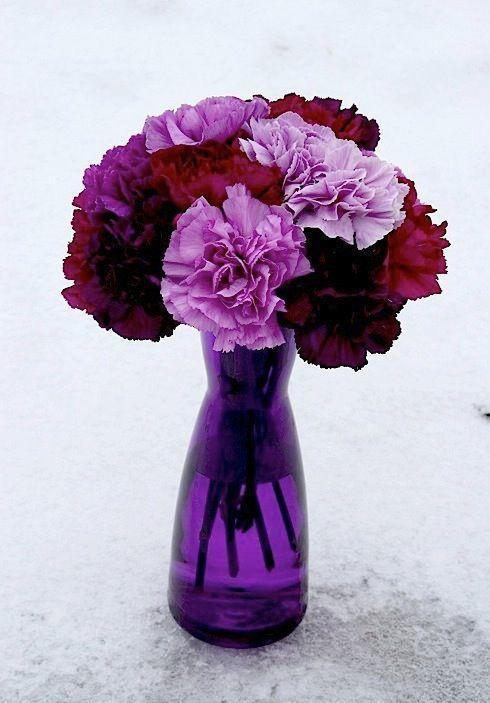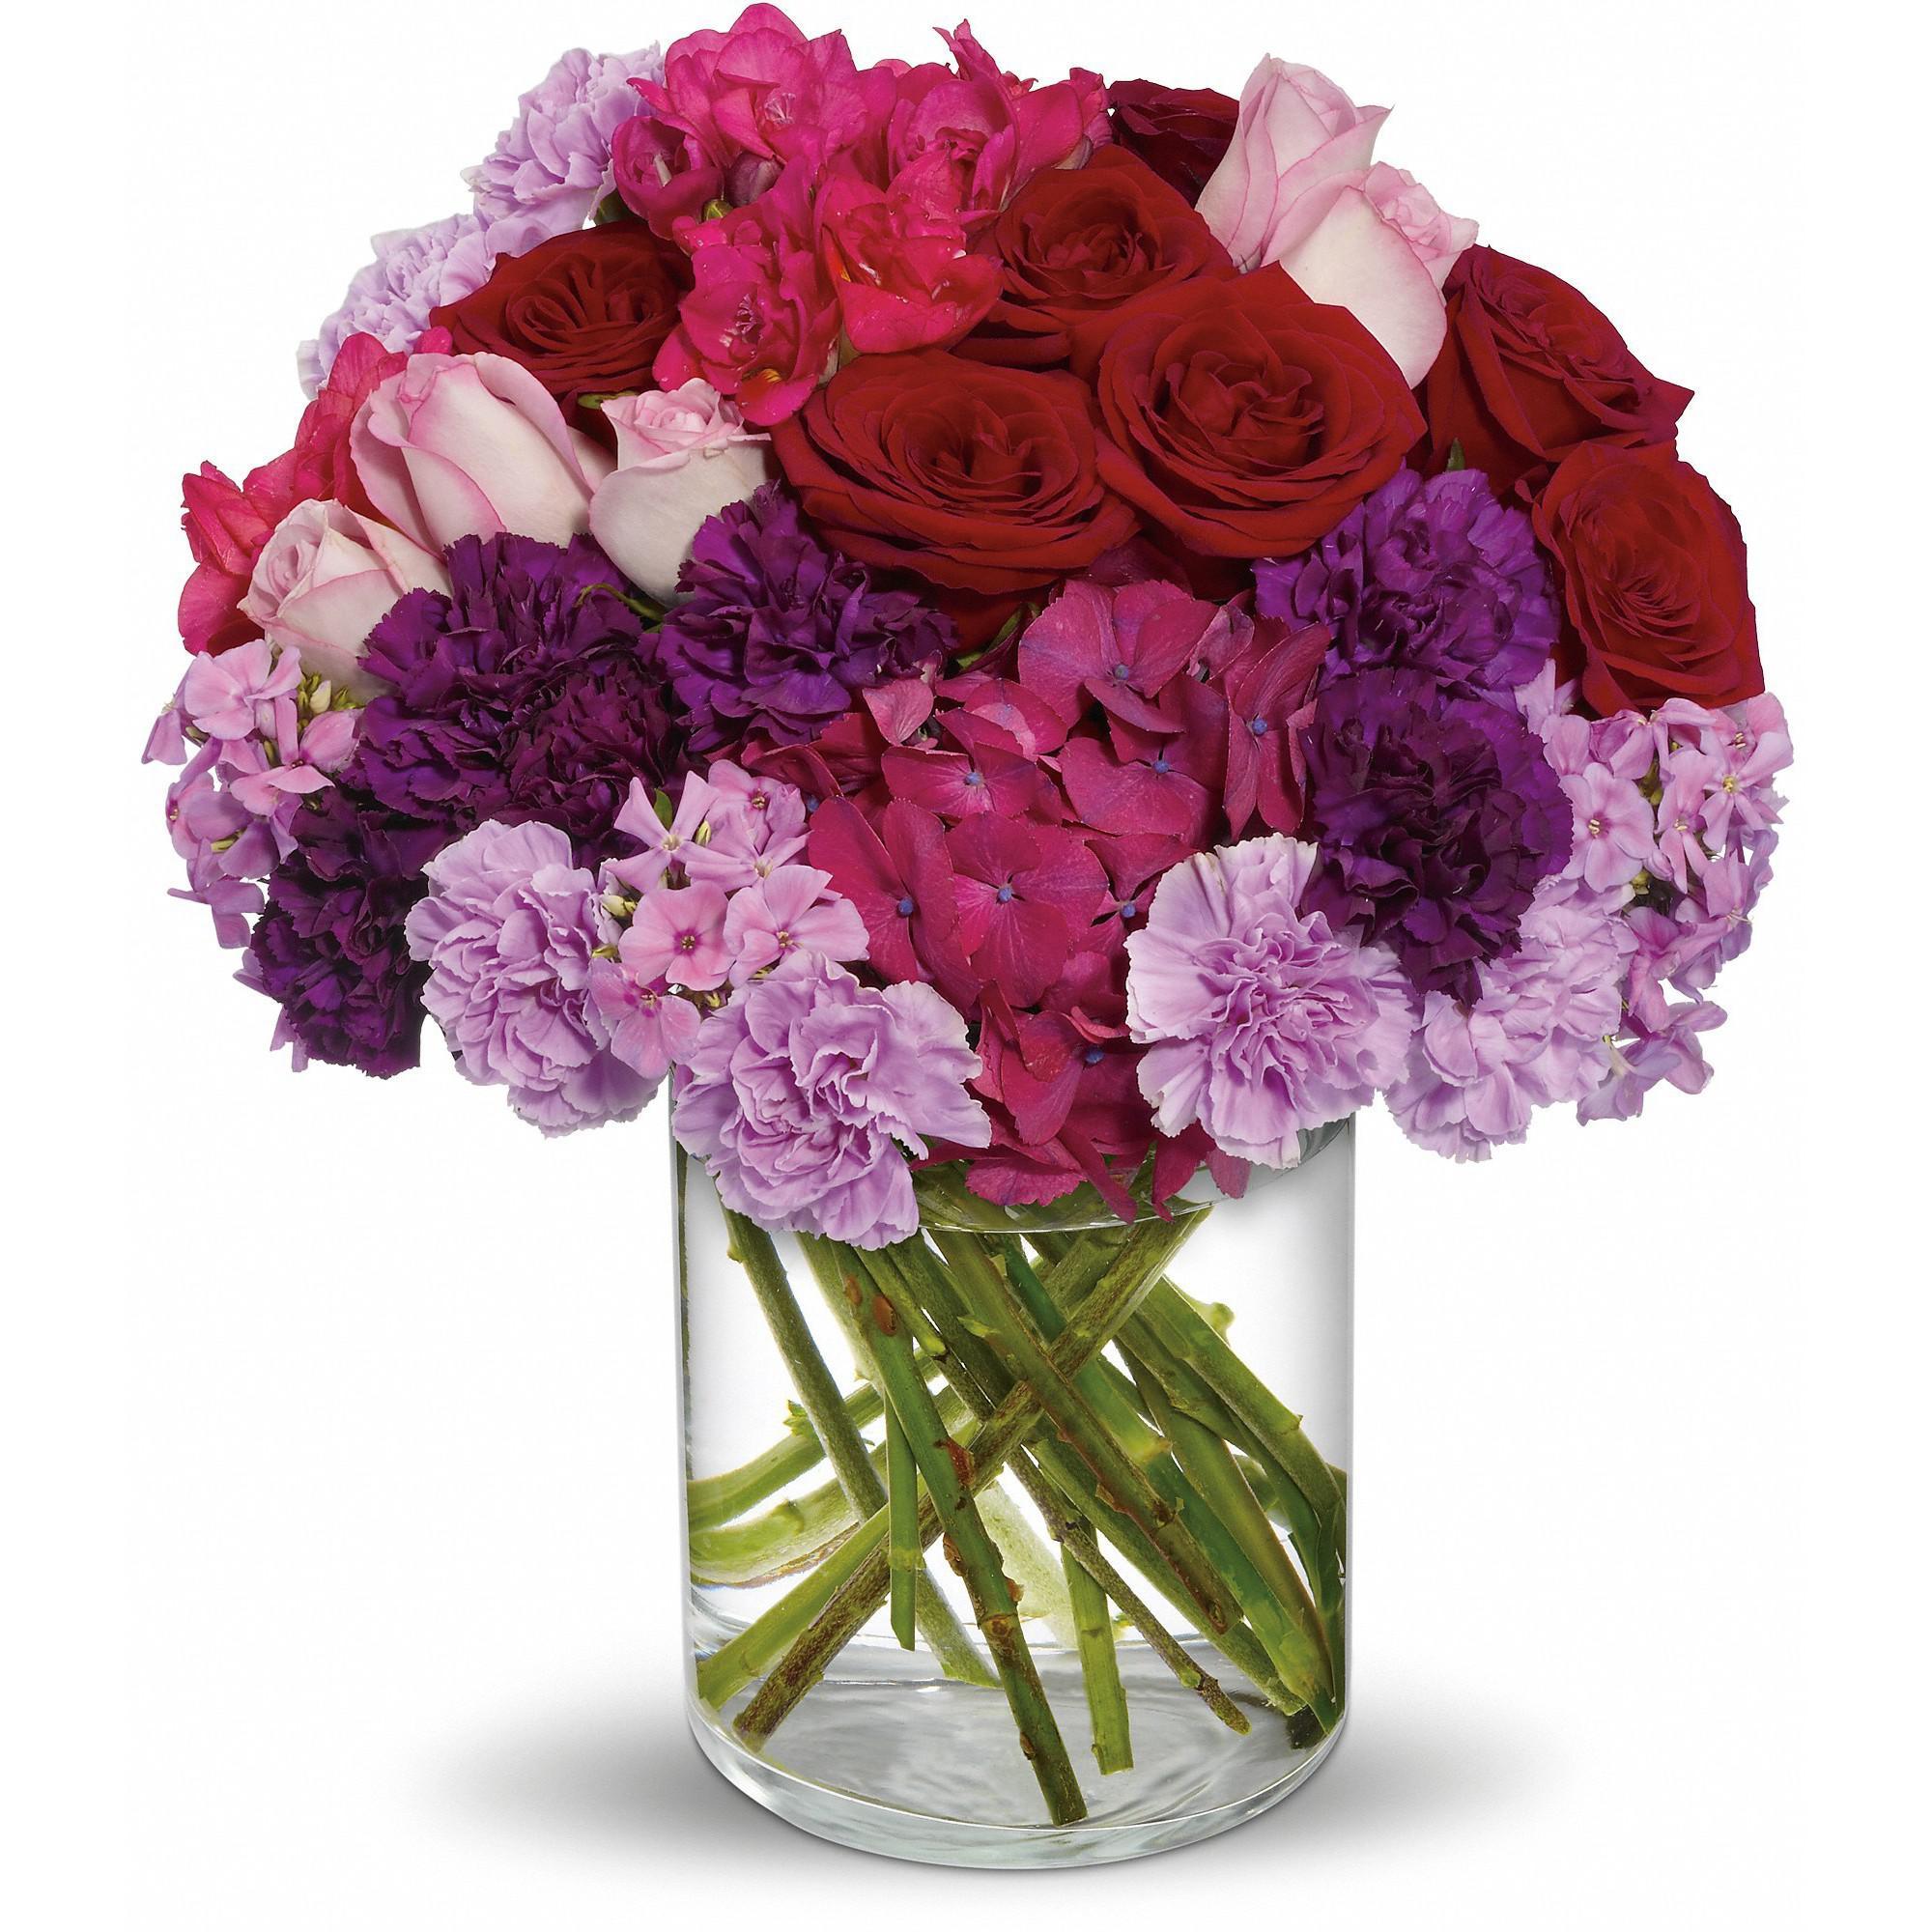The first image is the image on the left, the second image is the image on the right. Examine the images to the left and right. Is the description "One of the vases is purple." accurate? Answer yes or no. Yes. 